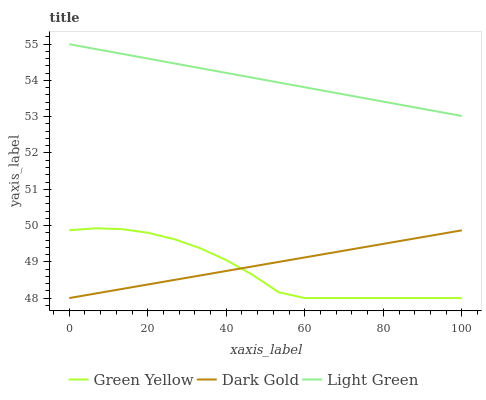Does Green Yellow have the minimum area under the curve?
Answer yes or no. Yes. Does Light Green have the maximum area under the curve?
Answer yes or no. Yes. Does Dark Gold have the minimum area under the curve?
Answer yes or no. No. Does Dark Gold have the maximum area under the curve?
Answer yes or no. No. Is Light Green the smoothest?
Answer yes or no. Yes. Is Green Yellow the roughest?
Answer yes or no. Yes. Is Dark Gold the smoothest?
Answer yes or no. No. Is Dark Gold the roughest?
Answer yes or no. No. Does Light Green have the lowest value?
Answer yes or no. No. Does Light Green have the highest value?
Answer yes or no. Yes. Does Dark Gold have the highest value?
Answer yes or no. No. Is Green Yellow less than Light Green?
Answer yes or no. Yes. Is Light Green greater than Dark Gold?
Answer yes or no. Yes. Does Green Yellow intersect Light Green?
Answer yes or no. No. 